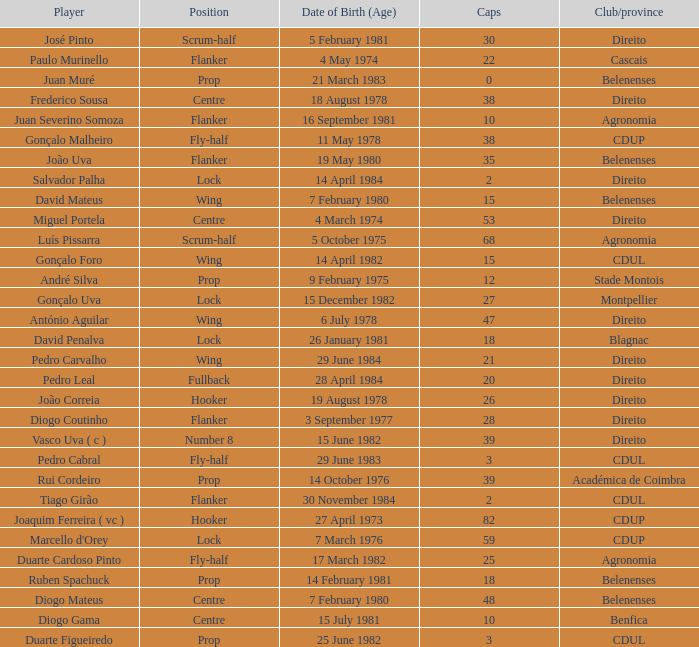Which player has a Club/province of direito, less than 21 caps, and a Position of lock? Salvador Palha. 